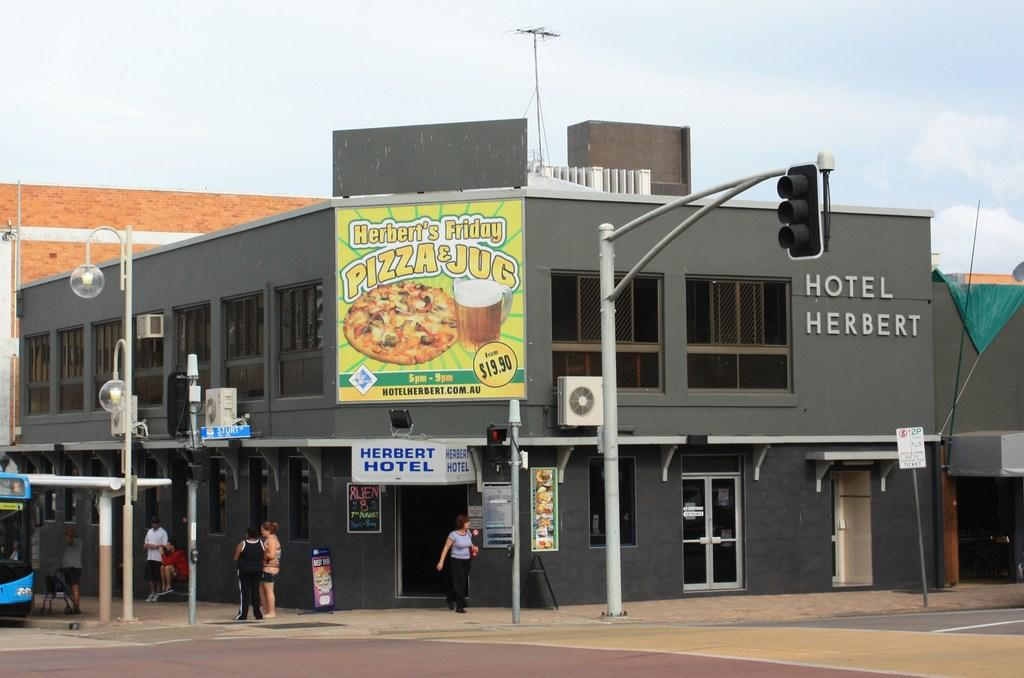What type of structures can be seen in the image? There are buildings in the image. What features are present on the buildings? There are doors and windows in the image. What traffic control device is visible in the image? There is a traffic signal in the image. What additional signage is present in the image? There is a banner in the image. What type of lighting is present in the image? There is a street lamp in the image. What mode of transportation is visible in the image? There is a bus in the image. Are there any people present in the image? Yes, there are people in the image. What is visible at the top of the image? The sky is visible at the top of the image. Can you describe the fog surrounding the buildings in the image? There is no fog present in the image; the sky is visible at the top of the image. How does the cub interact with the people in the image? There is no cub present in the image; it is not a subject or object in the image. 